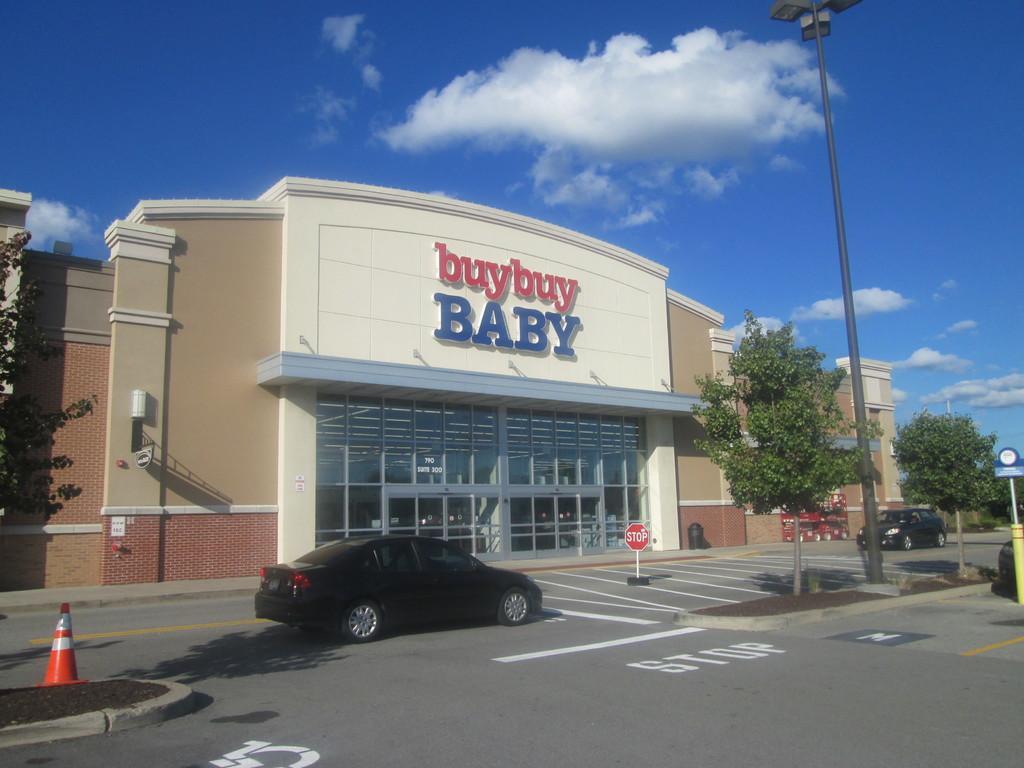Please provide a concise description of this image. In this image I can see two cars, sign boards, light poles, trees and stoppers on the road. In the background I can see buildings, glass windows and the sky. This image is taken may be on the road. 